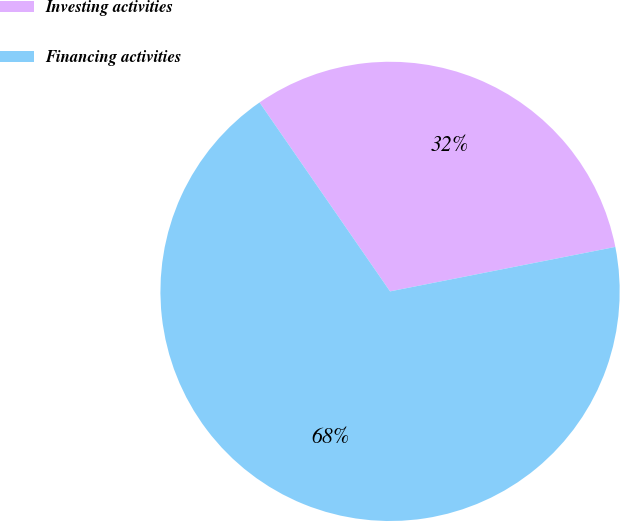Convert chart to OTSL. <chart><loc_0><loc_0><loc_500><loc_500><pie_chart><fcel>Investing activities<fcel>Financing activities<nl><fcel>31.52%<fcel>68.48%<nl></chart> 